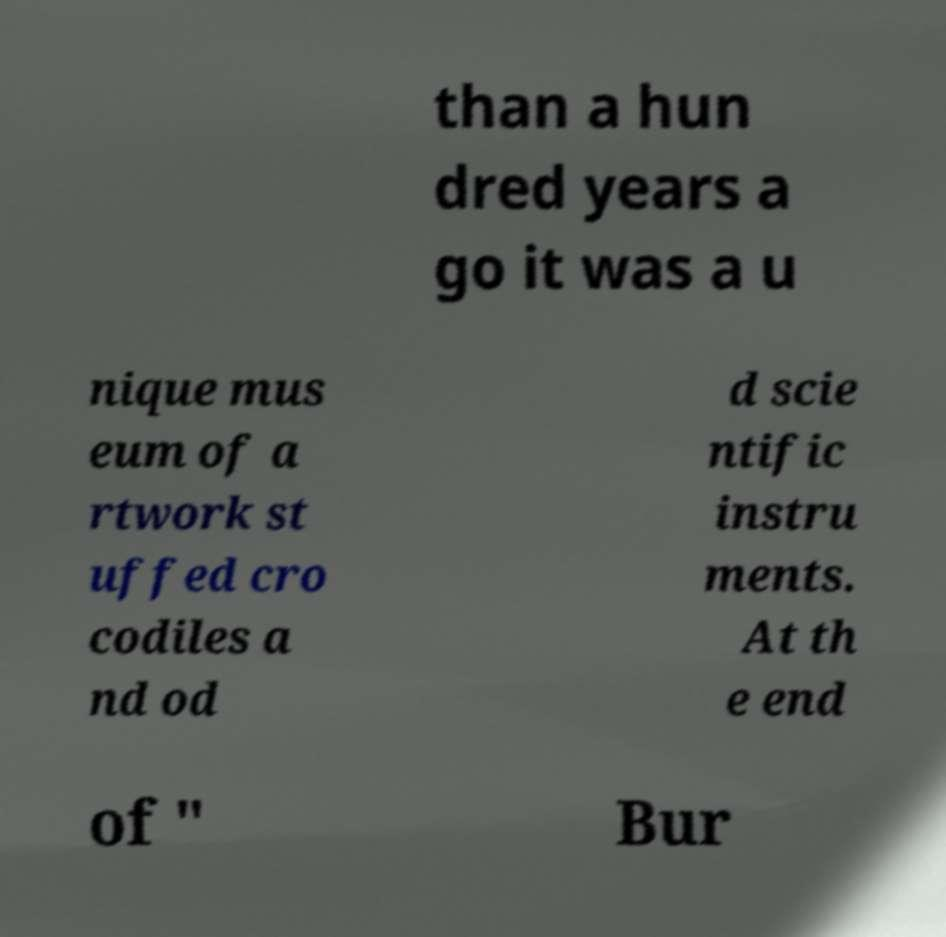There's text embedded in this image that I need extracted. Can you transcribe it verbatim? than a hun dred years a go it was a u nique mus eum of a rtwork st uffed cro codiles a nd od d scie ntific instru ments. At th e end of " Bur 